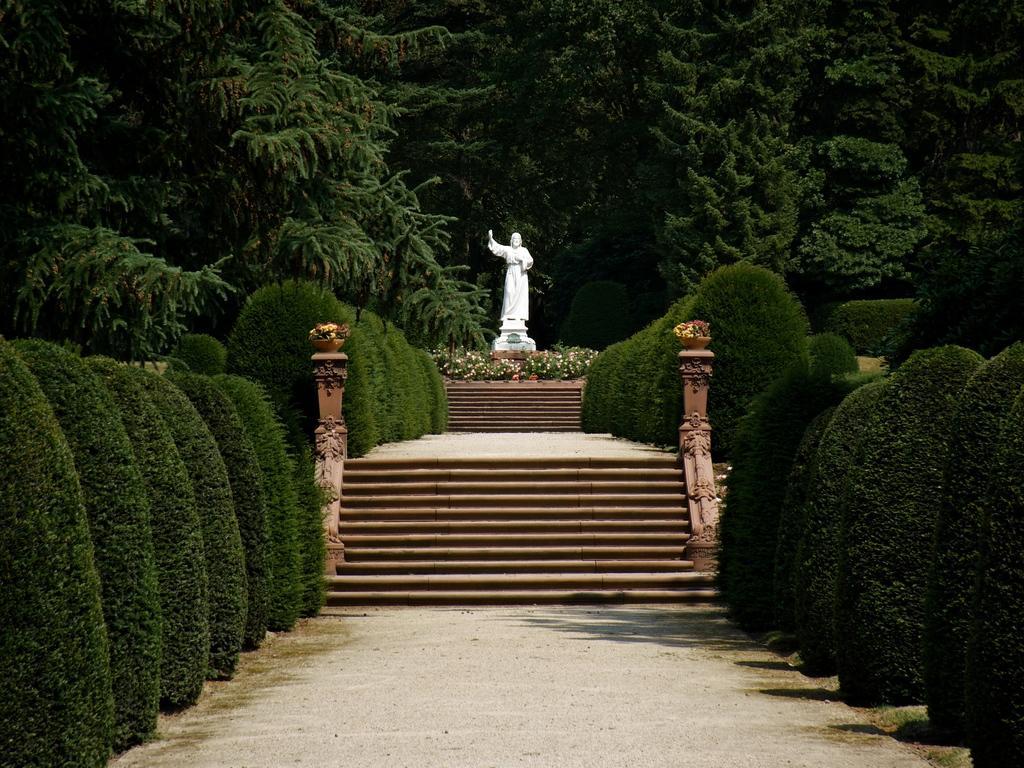Can you describe this image briefly? In the given image i can see a sculpture,flowers,trees,plants and stairs. 